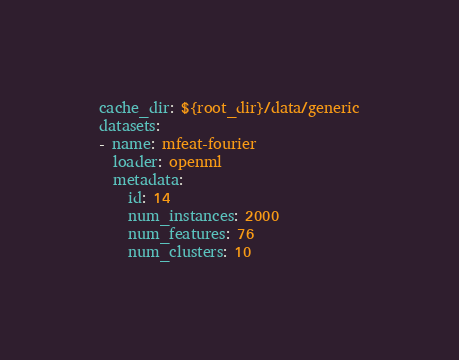<code> <loc_0><loc_0><loc_500><loc_500><_YAML_>cache_dir: ${root_dir}/data/generic
datasets:
- name: mfeat-fourier
  loader: openml
  metadata:
    id: 14
    num_instances: 2000
    num_features: 76
    num_clusters: 10
</code> 